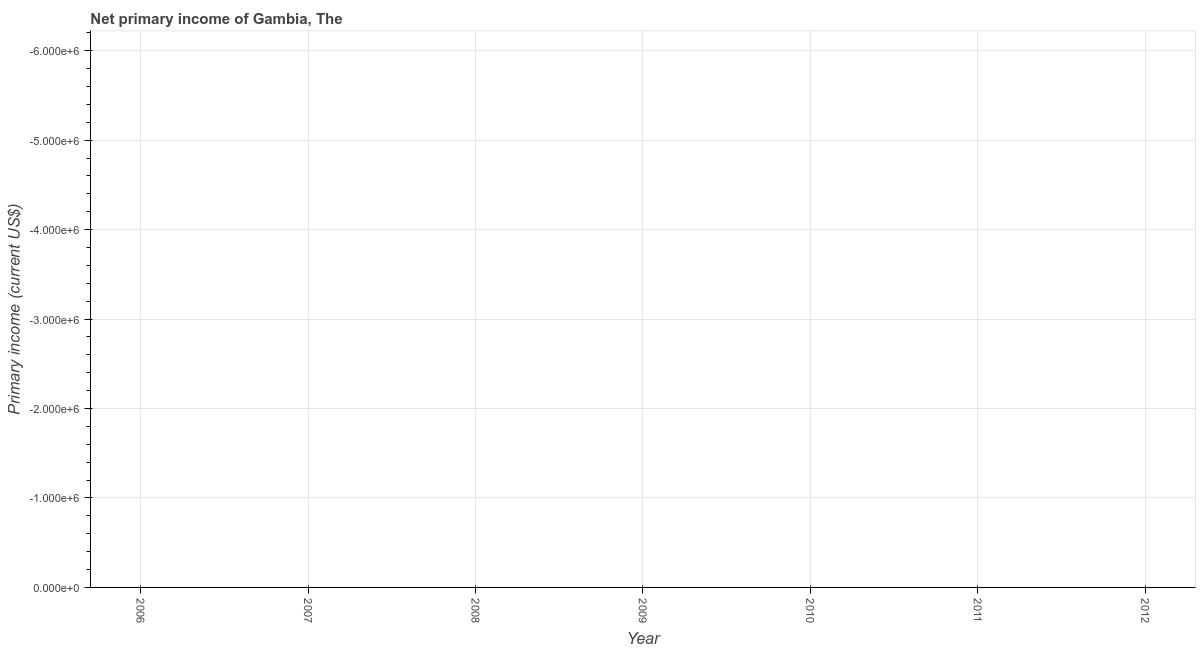What is the amount of primary income in 2011?
Provide a short and direct response. 0. What is the sum of the amount of primary income?
Provide a short and direct response. 0. What is the median amount of primary income?
Make the answer very short. 0. In how many years, is the amount of primary income greater than -1600000 US$?
Keep it short and to the point. 0. How many dotlines are there?
Your response must be concise. 0. What is the difference between two consecutive major ticks on the Y-axis?
Offer a very short reply. 1.00e+06. Are the values on the major ticks of Y-axis written in scientific E-notation?
Your response must be concise. Yes. Does the graph contain any zero values?
Give a very brief answer. Yes. Does the graph contain grids?
Make the answer very short. Yes. What is the title of the graph?
Keep it short and to the point. Net primary income of Gambia, The. What is the label or title of the X-axis?
Your answer should be very brief. Year. What is the label or title of the Y-axis?
Offer a terse response. Primary income (current US$). What is the Primary income (current US$) in 2006?
Provide a short and direct response. 0. What is the Primary income (current US$) in 2007?
Give a very brief answer. 0. What is the Primary income (current US$) in 2009?
Keep it short and to the point. 0. What is the Primary income (current US$) in 2010?
Ensure brevity in your answer.  0. 